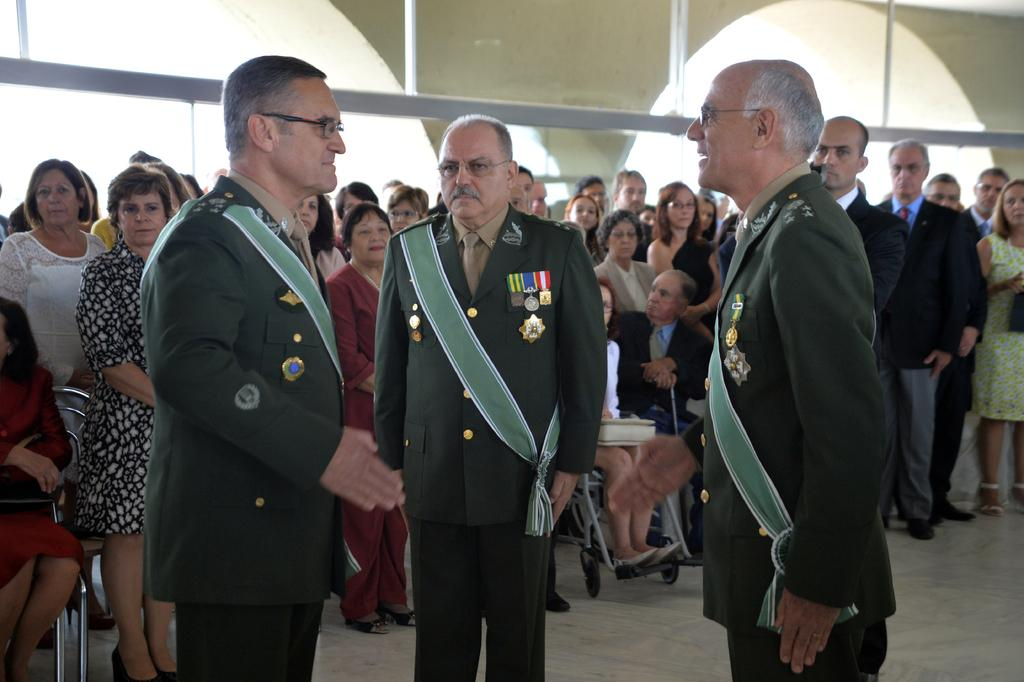What can be observed about the people in the image? There are people standing in the image. What surface are the people standing on? The people are standing on the floor. Can you identify the gender of the people in the image? There are men and women in the image. What type of camera is being used to take the picture of the people in the image? There is no camera present in the image, as it is a photograph of the people. 